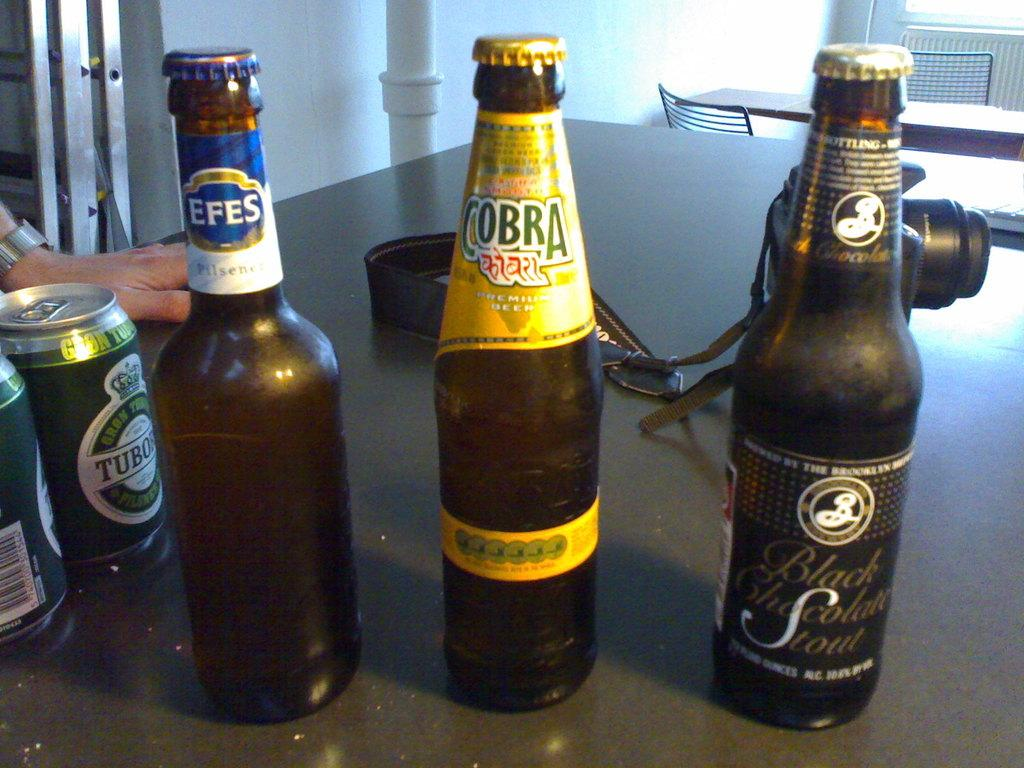Provide a one-sentence caption for the provided image. A bottle with cobra on the label is in between two others. 